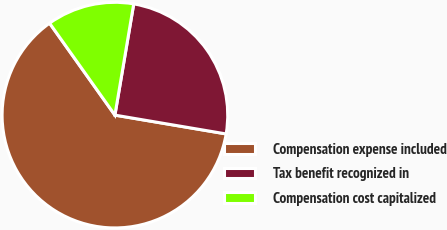Convert chart. <chart><loc_0><loc_0><loc_500><loc_500><pie_chart><fcel>Compensation expense included<fcel>Tax benefit recognized in<fcel>Compensation cost capitalized<nl><fcel>62.5%<fcel>25.0%<fcel>12.5%<nl></chart> 